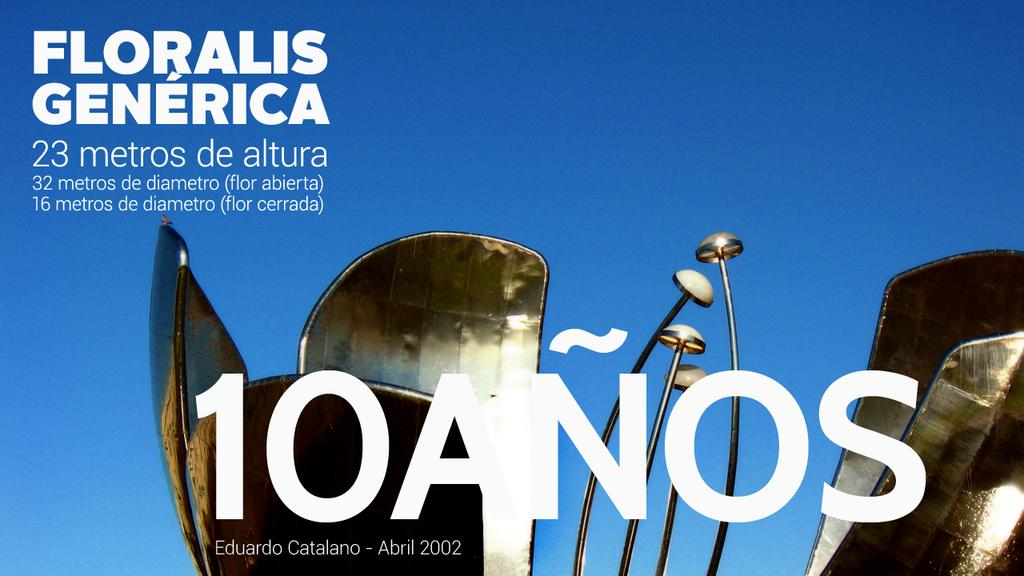<image>
Give a short and clear explanation of the subsequent image. an advertisement with the name Floralis on it 